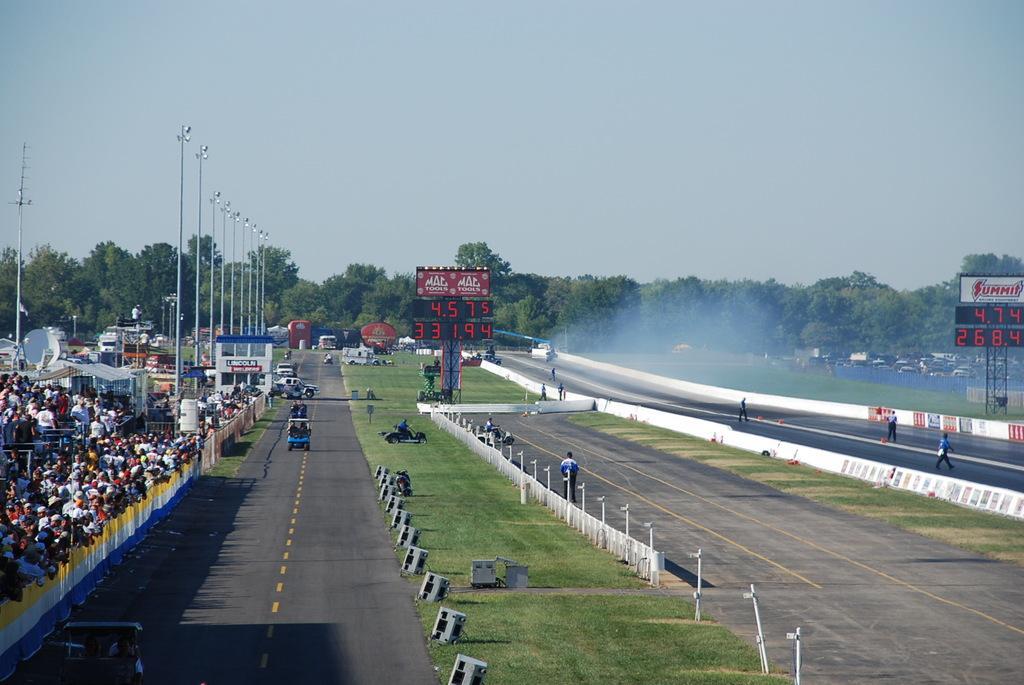Describe this image in one or two sentences. In this picture there are people and we can see vehicles on the road, lights, poles, boards, shed, building, grass, smoke and objects. In the background of the image we can see trees and sky. 